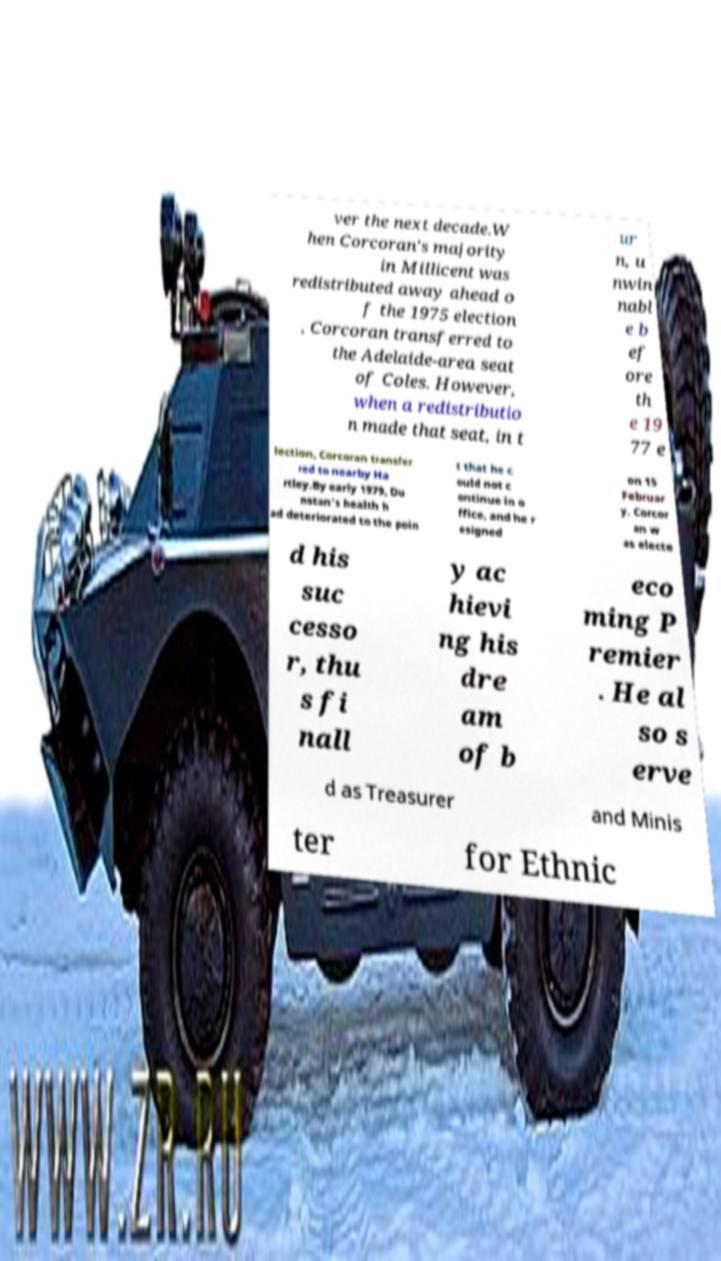I need the written content from this picture converted into text. Can you do that? ver the next decade.W hen Corcoran's majority in Millicent was redistributed away ahead o f the 1975 election , Corcoran transferred to the Adelaide-area seat of Coles. However, when a redistributio n made that seat, in t ur n, u nwin nabl e b ef ore th e 19 77 e lection, Corcoran transfer red to nearby Ha rtley.By early 1979, Du nstan's health h ad deteriorated to the poin t that he c ould not c ontinue in o ffice, and he r esigned on 15 Februar y. Corcor an w as electe d his suc cesso r, thu s fi nall y ac hievi ng his dre am of b eco ming P remier . He al so s erve d as Treasurer and Minis ter for Ethnic 